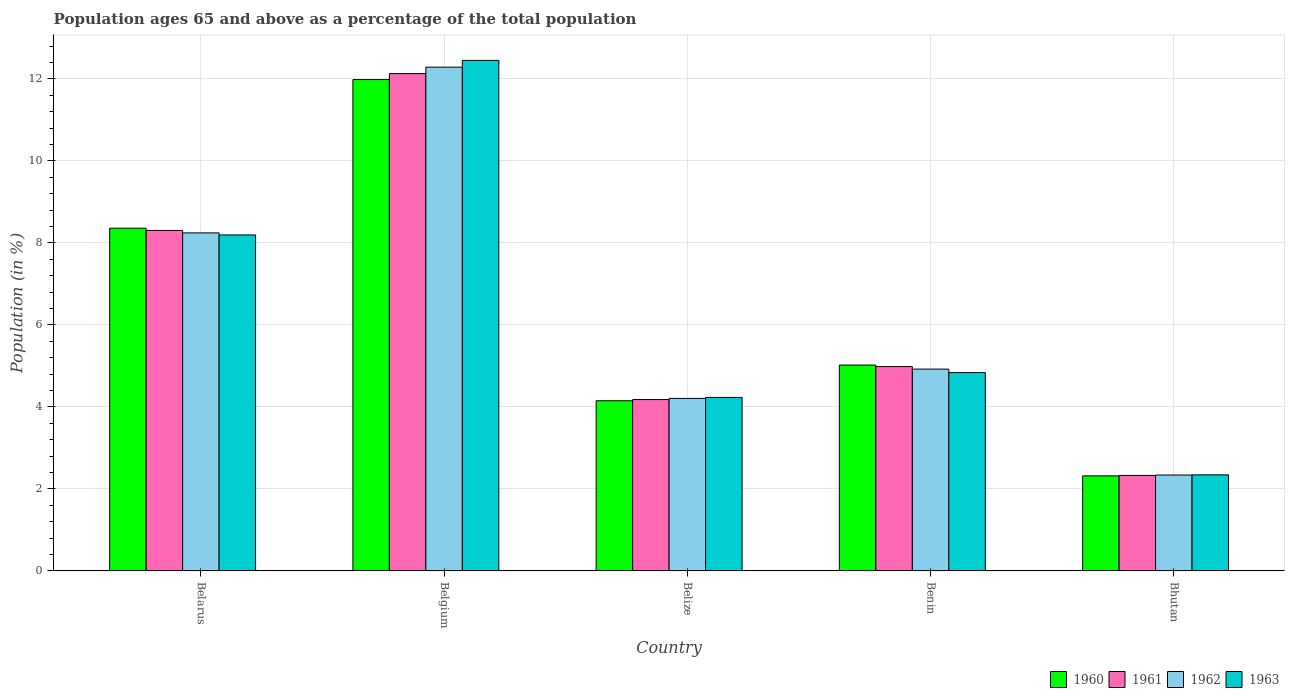Are the number of bars per tick equal to the number of legend labels?
Provide a succinct answer. Yes. How many bars are there on the 1st tick from the right?
Your answer should be compact. 4. What is the label of the 1st group of bars from the left?
Provide a short and direct response. Belarus. In how many cases, is the number of bars for a given country not equal to the number of legend labels?
Your response must be concise. 0. What is the percentage of the population ages 65 and above in 1963 in Bhutan?
Your response must be concise. 2.34. Across all countries, what is the maximum percentage of the population ages 65 and above in 1961?
Offer a terse response. 12.13. Across all countries, what is the minimum percentage of the population ages 65 and above in 1961?
Give a very brief answer. 2.33. In which country was the percentage of the population ages 65 and above in 1962 maximum?
Ensure brevity in your answer.  Belgium. In which country was the percentage of the population ages 65 and above in 1963 minimum?
Make the answer very short. Bhutan. What is the total percentage of the population ages 65 and above in 1961 in the graph?
Provide a short and direct response. 31.93. What is the difference between the percentage of the population ages 65 and above in 1960 in Belarus and that in Belgium?
Your answer should be very brief. -3.63. What is the difference between the percentage of the population ages 65 and above in 1960 in Benin and the percentage of the population ages 65 and above in 1963 in Belize?
Provide a short and direct response. 0.79. What is the average percentage of the population ages 65 and above in 1962 per country?
Your answer should be very brief. 6.4. What is the difference between the percentage of the population ages 65 and above of/in 1960 and percentage of the population ages 65 and above of/in 1963 in Bhutan?
Give a very brief answer. -0.03. In how many countries, is the percentage of the population ages 65 and above in 1961 greater than 12?
Ensure brevity in your answer.  1. What is the ratio of the percentage of the population ages 65 and above in 1961 in Belarus to that in Bhutan?
Offer a terse response. 3.57. What is the difference between the highest and the second highest percentage of the population ages 65 and above in 1961?
Offer a terse response. -3.83. What is the difference between the highest and the lowest percentage of the population ages 65 and above in 1963?
Offer a very short reply. 10.11. In how many countries, is the percentage of the population ages 65 and above in 1962 greater than the average percentage of the population ages 65 and above in 1962 taken over all countries?
Offer a very short reply. 2. Is it the case that in every country, the sum of the percentage of the population ages 65 and above in 1960 and percentage of the population ages 65 and above in 1961 is greater than the sum of percentage of the population ages 65 and above in 1963 and percentage of the population ages 65 and above in 1962?
Provide a succinct answer. No. What does the 2nd bar from the left in Belize represents?
Keep it short and to the point. 1961. Is it the case that in every country, the sum of the percentage of the population ages 65 and above in 1962 and percentage of the population ages 65 and above in 1960 is greater than the percentage of the population ages 65 and above in 1963?
Give a very brief answer. Yes. Are the values on the major ticks of Y-axis written in scientific E-notation?
Make the answer very short. No. Does the graph contain any zero values?
Keep it short and to the point. No. Where does the legend appear in the graph?
Keep it short and to the point. Bottom right. How many legend labels are there?
Keep it short and to the point. 4. What is the title of the graph?
Your response must be concise. Population ages 65 and above as a percentage of the total population. What is the label or title of the X-axis?
Your answer should be very brief. Country. What is the label or title of the Y-axis?
Give a very brief answer. Population (in %). What is the Population (in %) in 1960 in Belarus?
Make the answer very short. 8.36. What is the Population (in %) in 1961 in Belarus?
Your answer should be compact. 8.3. What is the Population (in %) of 1962 in Belarus?
Provide a succinct answer. 8.25. What is the Population (in %) in 1963 in Belarus?
Offer a terse response. 8.2. What is the Population (in %) in 1960 in Belgium?
Provide a short and direct response. 11.99. What is the Population (in %) of 1961 in Belgium?
Offer a terse response. 12.13. What is the Population (in %) in 1962 in Belgium?
Your answer should be compact. 12.29. What is the Population (in %) in 1963 in Belgium?
Keep it short and to the point. 12.45. What is the Population (in %) of 1960 in Belize?
Make the answer very short. 4.15. What is the Population (in %) in 1961 in Belize?
Make the answer very short. 4.18. What is the Population (in %) in 1962 in Belize?
Your response must be concise. 4.21. What is the Population (in %) of 1963 in Belize?
Give a very brief answer. 4.23. What is the Population (in %) in 1960 in Benin?
Your answer should be very brief. 5.02. What is the Population (in %) in 1961 in Benin?
Make the answer very short. 4.98. What is the Population (in %) in 1962 in Benin?
Your answer should be compact. 4.92. What is the Population (in %) in 1963 in Benin?
Your answer should be compact. 4.84. What is the Population (in %) of 1960 in Bhutan?
Offer a terse response. 2.32. What is the Population (in %) of 1961 in Bhutan?
Offer a very short reply. 2.33. What is the Population (in %) in 1962 in Bhutan?
Ensure brevity in your answer.  2.34. What is the Population (in %) in 1963 in Bhutan?
Your answer should be very brief. 2.34. Across all countries, what is the maximum Population (in %) of 1960?
Provide a short and direct response. 11.99. Across all countries, what is the maximum Population (in %) in 1961?
Ensure brevity in your answer.  12.13. Across all countries, what is the maximum Population (in %) in 1962?
Make the answer very short. 12.29. Across all countries, what is the maximum Population (in %) of 1963?
Provide a succinct answer. 12.45. Across all countries, what is the minimum Population (in %) in 1960?
Keep it short and to the point. 2.32. Across all countries, what is the minimum Population (in %) of 1961?
Offer a terse response. 2.33. Across all countries, what is the minimum Population (in %) in 1962?
Your response must be concise. 2.34. Across all countries, what is the minimum Population (in %) in 1963?
Give a very brief answer. 2.34. What is the total Population (in %) in 1960 in the graph?
Your response must be concise. 31.83. What is the total Population (in %) in 1961 in the graph?
Your response must be concise. 31.93. What is the total Population (in %) in 1962 in the graph?
Give a very brief answer. 32. What is the total Population (in %) of 1963 in the graph?
Offer a very short reply. 32.06. What is the difference between the Population (in %) of 1960 in Belarus and that in Belgium?
Make the answer very short. -3.63. What is the difference between the Population (in %) of 1961 in Belarus and that in Belgium?
Offer a terse response. -3.83. What is the difference between the Population (in %) in 1962 in Belarus and that in Belgium?
Your answer should be very brief. -4.04. What is the difference between the Population (in %) of 1963 in Belarus and that in Belgium?
Ensure brevity in your answer.  -4.26. What is the difference between the Population (in %) of 1960 in Belarus and that in Belize?
Ensure brevity in your answer.  4.21. What is the difference between the Population (in %) in 1961 in Belarus and that in Belize?
Make the answer very short. 4.13. What is the difference between the Population (in %) in 1962 in Belarus and that in Belize?
Offer a terse response. 4.04. What is the difference between the Population (in %) of 1963 in Belarus and that in Belize?
Provide a succinct answer. 3.96. What is the difference between the Population (in %) of 1960 in Belarus and that in Benin?
Provide a short and direct response. 3.34. What is the difference between the Population (in %) in 1961 in Belarus and that in Benin?
Your answer should be compact. 3.32. What is the difference between the Population (in %) in 1962 in Belarus and that in Benin?
Your answer should be very brief. 3.32. What is the difference between the Population (in %) of 1963 in Belarus and that in Benin?
Keep it short and to the point. 3.36. What is the difference between the Population (in %) in 1960 in Belarus and that in Bhutan?
Your answer should be very brief. 6.04. What is the difference between the Population (in %) of 1961 in Belarus and that in Bhutan?
Your answer should be very brief. 5.98. What is the difference between the Population (in %) of 1962 in Belarus and that in Bhutan?
Provide a succinct answer. 5.91. What is the difference between the Population (in %) in 1963 in Belarus and that in Bhutan?
Your response must be concise. 5.85. What is the difference between the Population (in %) of 1960 in Belgium and that in Belize?
Your response must be concise. 7.84. What is the difference between the Population (in %) of 1961 in Belgium and that in Belize?
Offer a terse response. 7.95. What is the difference between the Population (in %) in 1962 in Belgium and that in Belize?
Provide a short and direct response. 8.08. What is the difference between the Population (in %) in 1963 in Belgium and that in Belize?
Make the answer very short. 8.22. What is the difference between the Population (in %) of 1960 in Belgium and that in Benin?
Keep it short and to the point. 6.96. What is the difference between the Population (in %) in 1961 in Belgium and that in Benin?
Offer a terse response. 7.15. What is the difference between the Population (in %) of 1962 in Belgium and that in Benin?
Your answer should be very brief. 7.37. What is the difference between the Population (in %) in 1963 in Belgium and that in Benin?
Your answer should be very brief. 7.62. What is the difference between the Population (in %) of 1960 in Belgium and that in Bhutan?
Give a very brief answer. 9.67. What is the difference between the Population (in %) of 1961 in Belgium and that in Bhutan?
Provide a succinct answer. 9.8. What is the difference between the Population (in %) of 1962 in Belgium and that in Bhutan?
Offer a terse response. 9.95. What is the difference between the Population (in %) of 1963 in Belgium and that in Bhutan?
Give a very brief answer. 10.11. What is the difference between the Population (in %) of 1960 in Belize and that in Benin?
Your response must be concise. -0.87. What is the difference between the Population (in %) of 1961 in Belize and that in Benin?
Give a very brief answer. -0.8. What is the difference between the Population (in %) of 1962 in Belize and that in Benin?
Give a very brief answer. -0.71. What is the difference between the Population (in %) in 1963 in Belize and that in Benin?
Provide a short and direct response. -0.61. What is the difference between the Population (in %) in 1960 in Belize and that in Bhutan?
Your answer should be very brief. 1.83. What is the difference between the Population (in %) in 1961 in Belize and that in Bhutan?
Your answer should be very brief. 1.85. What is the difference between the Population (in %) in 1962 in Belize and that in Bhutan?
Your response must be concise. 1.87. What is the difference between the Population (in %) in 1963 in Belize and that in Bhutan?
Offer a very short reply. 1.89. What is the difference between the Population (in %) of 1960 in Benin and that in Bhutan?
Give a very brief answer. 2.7. What is the difference between the Population (in %) of 1961 in Benin and that in Bhutan?
Your answer should be very brief. 2.65. What is the difference between the Population (in %) of 1962 in Benin and that in Bhutan?
Make the answer very short. 2.58. What is the difference between the Population (in %) of 1963 in Benin and that in Bhutan?
Offer a terse response. 2.49. What is the difference between the Population (in %) of 1960 in Belarus and the Population (in %) of 1961 in Belgium?
Keep it short and to the point. -3.77. What is the difference between the Population (in %) of 1960 in Belarus and the Population (in %) of 1962 in Belgium?
Offer a terse response. -3.93. What is the difference between the Population (in %) of 1960 in Belarus and the Population (in %) of 1963 in Belgium?
Your answer should be very brief. -4.09. What is the difference between the Population (in %) in 1961 in Belarus and the Population (in %) in 1962 in Belgium?
Provide a succinct answer. -3.98. What is the difference between the Population (in %) in 1961 in Belarus and the Population (in %) in 1963 in Belgium?
Keep it short and to the point. -4.15. What is the difference between the Population (in %) of 1962 in Belarus and the Population (in %) of 1963 in Belgium?
Keep it short and to the point. -4.21. What is the difference between the Population (in %) in 1960 in Belarus and the Population (in %) in 1961 in Belize?
Your response must be concise. 4.18. What is the difference between the Population (in %) of 1960 in Belarus and the Population (in %) of 1962 in Belize?
Provide a succinct answer. 4.15. What is the difference between the Population (in %) in 1960 in Belarus and the Population (in %) in 1963 in Belize?
Your response must be concise. 4.13. What is the difference between the Population (in %) of 1961 in Belarus and the Population (in %) of 1962 in Belize?
Your answer should be compact. 4.1. What is the difference between the Population (in %) of 1961 in Belarus and the Population (in %) of 1963 in Belize?
Offer a very short reply. 4.07. What is the difference between the Population (in %) of 1962 in Belarus and the Population (in %) of 1963 in Belize?
Your answer should be very brief. 4.01. What is the difference between the Population (in %) in 1960 in Belarus and the Population (in %) in 1961 in Benin?
Make the answer very short. 3.38. What is the difference between the Population (in %) of 1960 in Belarus and the Population (in %) of 1962 in Benin?
Offer a very short reply. 3.44. What is the difference between the Population (in %) of 1960 in Belarus and the Population (in %) of 1963 in Benin?
Provide a short and direct response. 3.52. What is the difference between the Population (in %) of 1961 in Belarus and the Population (in %) of 1962 in Benin?
Provide a short and direct response. 3.38. What is the difference between the Population (in %) of 1961 in Belarus and the Population (in %) of 1963 in Benin?
Provide a succinct answer. 3.47. What is the difference between the Population (in %) of 1962 in Belarus and the Population (in %) of 1963 in Benin?
Offer a very short reply. 3.41. What is the difference between the Population (in %) of 1960 in Belarus and the Population (in %) of 1961 in Bhutan?
Offer a terse response. 6.03. What is the difference between the Population (in %) of 1960 in Belarus and the Population (in %) of 1962 in Bhutan?
Give a very brief answer. 6.02. What is the difference between the Population (in %) of 1960 in Belarus and the Population (in %) of 1963 in Bhutan?
Make the answer very short. 6.02. What is the difference between the Population (in %) of 1961 in Belarus and the Population (in %) of 1962 in Bhutan?
Provide a short and direct response. 5.97. What is the difference between the Population (in %) of 1961 in Belarus and the Population (in %) of 1963 in Bhutan?
Ensure brevity in your answer.  5.96. What is the difference between the Population (in %) in 1962 in Belarus and the Population (in %) in 1963 in Bhutan?
Give a very brief answer. 5.9. What is the difference between the Population (in %) of 1960 in Belgium and the Population (in %) of 1961 in Belize?
Give a very brief answer. 7.81. What is the difference between the Population (in %) of 1960 in Belgium and the Population (in %) of 1962 in Belize?
Keep it short and to the point. 7.78. What is the difference between the Population (in %) in 1960 in Belgium and the Population (in %) in 1963 in Belize?
Offer a very short reply. 7.75. What is the difference between the Population (in %) in 1961 in Belgium and the Population (in %) in 1962 in Belize?
Provide a succinct answer. 7.92. What is the difference between the Population (in %) of 1961 in Belgium and the Population (in %) of 1963 in Belize?
Give a very brief answer. 7.9. What is the difference between the Population (in %) in 1962 in Belgium and the Population (in %) in 1963 in Belize?
Ensure brevity in your answer.  8.06. What is the difference between the Population (in %) in 1960 in Belgium and the Population (in %) in 1961 in Benin?
Your answer should be compact. 7. What is the difference between the Population (in %) of 1960 in Belgium and the Population (in %) of 1962 in Benin?
Provide a succinct answer. 7.06. What is the difference between the Population (in %) of 1960 in Belgium and the Population (in %) of 1963 in Benin?
Your response must be concise. 7.15. What is the difference between the Population (in %) in 1961 in Belgium and the Population (in %) in 1962 in Benin?
Keep it short and to the point. 7.21. What is the difference between the Population (in %) of 1961 in Belgium and the Population (in %) of 1963 in Benin?
Your answer should be very brief. 7.29. What is the difference between the Population (in %) of 1962 in Belgium and the Population (in %) of 1963 in Benin?
Offer a terse response. 7.45. What is the difference between the Population (in %) in 1960 in Belgium and the Population (in %) in 1961 in Bhutan?
Provide a succinct answer. 9.66. What is the difference between the Population (in %) of 1960 in Belgium and the Population (in %) of 1962 in Bhutan?
Your answer should be very brief. 9.65. What is the difference between the Population (in %) in 1960 in Belgium and the Population (in %) in 1963 in Bhutan?
Offer a terse response. 9.64. What is the difference between the Population (in %) of 1961 in Belgium and the Population (in %) of 1962 in Bhutan?
Your response must be concise. 9.79. What is the difference between the Population (in %) of 1961 in Belgium and the Population (in %) of 1963 in Bhutan?
Your answer should be compact. 9.79. What is the difference between the Population (in %) in 1962 in Belgium and the Population (in %) in 1963 in Bhutan?
Your response must be concise. 9.95. What is the difference between the Population (in %) of 1960 in Belize and the Population (in %) of 1961 in Benin?
Give a very brief answer. -0.83. What is the difference between the Population (in %) in 1960 in Belize and the Population (in %) in 1962 in Benin?
Your response must be concise. -0.77. What is the difference between the Population (in %) of 1960 in Belize and the Population (in %) of 1963 in Benin?
Provide a short and direct response. -0.69. What is the difference between the Population (in %) of 1961 in Belize and the Population (in %) of 1962 in Benin?
Offer a terse response. -0.74. What is the difference between the Population (in %) in 1961 in Belize and the Population (in %) in 1963 in Benin?
Make the answer very short. -0.66. What is the difference between the Population (in %) of 1962 in Belize and the Population (in %) of 1963 in Benin?
Make the answer very short. -0.63. What is the difference between the Population (in %) in 1960 in Belize and the Population (in %) in 1961 in Bhutan?
Offer a terse response. 1.82. What is the difference between the Population (in %) in 1960 in Belize and the Population (in %) in 1962 in Bhutan?
Your answer should be compact. 1.81. What is the difference between the Population (in %) of 1960 in Belize and the Population (in %) of 1963 in Bhutan?
Keep it short and to the point. 1.81. What is the difference between the Population (in %) in 1961 in Belize and the Population (in %) in 1962 in Bhutan?
Ensure brevity in your answer.  1.84. What is the difference between the Population (in %) in 1961 in Belize and the Population (in %) in 1963 in Bhutan?
Ensure brevity in your answer.  1.84. What is the difference between the Population (in %) in 1962 in Belize and the Population (in %) in 1963 in Bhutan?
Offer a terse response. 1.87. What is the difference between the Population (in %) of 1960 in Benin and the Population (in %) of 1961 in Bhutan?
Provide a short and direct response. 2.69. What is the difference between the Population (in %) of 1960 in Benin and the Population (in %) of 1962 in Bhutan?
Provide a succinct answer. 2.68. What is the difference between the Population (in %) in 1960 in Benin and the Population (in %) in 1963 in Bhutan?
Make the answer very short. 2.68. What is the difference between the Population (in %) of 1961 in Benin and the Population (in %) of 1962 in Bhutan?
Your response must be concise. 2.65. What is the difference between the Population (in %) of 1961 in Benin and the Population (in %) of 1963 in Bhutan?
Your answer should be compact. 2.64. What is the difference between the Population (in %) in 1962 in Benin and the Population (in %) in 1963 in Bhutan?
Your answer should be compact. 2.58. What is the average Population (in %) in 1960 per country?
Your answer should be compact. 6.37. What is the average Population (in %) in 1961 per country?
Your response must be concise. 6.39. What is the average Population (in %) of 1962 per country?
Make the answer very short. 6.4. What is the average Population (in %) in 1963 per country?
Offer a terse response. 6.41. What is the difference between the Population (in %) in 1960 and Population (in %) in 1961 in Belarus?
Offer a terse response. 0.05. What is the difference between the Population (in %) in 1960 and Population (in %) in 1962 in Belarus?
Provide a succinct answer. 0.11. What is the difference between the Population (in %) of 1960 and Population (in %) of 1963 in Belarus?
Offer a terse response. 0.16. What is the difference between the Population (in %) in 1961 and Population (in %) in 1962 in Belarus?
Offer a very short reply. 0.06. What is the difference between the Population (in %) in 1961 and Population (in %) in 1963 in Belarus?
Your answer should be very brief. 0.11. What is the difference between the Population (in %) in 1962 and Population (in %) in 1963 in Belarus?
Make the answer very short. 0.05. What is the difference between the Population (in %) of 1960 and Population (in %) of 1961 in Belgium?
Provide a short and direct response. -0.15. What is the difference between the Population (in %) of 1960 and Population (in %) of 1962 in Belgium?
Your response must be concise. -0.3. What is the difference between the Population (in %) in 1960 and Population (in %) in 1963 in Belgium?
Provide a succinct answer. -0.47. What is the difference between the Population (in %) in 1961 and Population (in %) in 1962 in Belgium?
Provide a short and direct response. -0.16. What is the difference between the Population (in %) in 1961 and Population (in %) in 1963 in Belgium?
Your answer should be very brief. -0.32. What is the difference between the Population (in %) in 1962 and Population (in %) in 1963 in Belgium?
Provide a short and direct response. -0.16. What is the difference between the Population (in %) of 1960 and Population (in %) of 1961 in Belize?
Provide a succinct answer. -0.03. What is the difference between the Population (in %) in 1960 and Population (in %) in 1962 in Belize?
Keep it short and to the point. -0.06. What is the difference between the Population (in %) of 1960 and Population (in %) of 1963 in Belize?
Your answer should be very brief. -0.08. What is the difference between the Population (in %) of 1961 and Population (in %) of 1962 in Belize?
Offer a terse response. -0.03. What is the difference between the Population (in %) in 1961 and Population (in %) in 1963 in Belize?
Make the answer very short. -0.05. What is the difference between the Population (in %) of 1962 and Population (in %) of 1963 in Belize?
Offer a very short reply. -0.02. What is the difference between the Population (in %) of 1960 and Population (in %) of 1961 in Benin?
Your answer should be very brief. 0.04. What is the difference between the Population (in %) of 1960 and Population (in %) of 1962 in Benin?
Keep it short and to the point. 0.1. What is the difference between the Population (in %) in 1960 and Population (in %) in 1963 in Benin?
Offer a very short reply. 0.18. What is the difference between the Population (in %) in 1961 and Population (in %) in 1962 in Benin?
Ensure brevity in your answer.  0.06. What is the difference between the Population (in %) of 1961 and Population (in %) of 1963 in Benin?
Your answer should be very brief. 0.15. What is the difference between the Population (in %) of 1962 and Population (in %) of 1963 in Benin?
Your answer should be compact. 0.09. What is the difference between the Population (in %) of 1960 and Population (in %) of 1961 in Bhutan?
Provide a succinct answer. -0.01. What is the difference between the Population (in %) in 1960 and Population (in %) in 1962 in Bhutan?
Your answer should be compact. -0.02. What is the difference between the Population (in %) of 1960 and Population (in %) of 1963 in Bhutan?
Your answer should be compact. -0.03. What is the difference between the Population (in %) of 1961 and Population (in %) of 1962 in Bhutan?
Offer a terse response. -0.01. What is the difference between the Population (in %) of 1961 and Population (in %) of 1963 in Bhutan?
Give a very brief answer. -0.01. What is the difference between the Population (in %) in 1962 and Population (in %) in 1963 in Bhutan?
Offer a terse response. -0. What is the ratio of the Population (in %) of 1960 in Belarus to that in Belgium?
Your answer should be compact. 0.7. What is the ratio of the Population (in %) of 1961 in Belarus to that in Belgium?
Provide a short and direct response. 0.68. What is the ratio of the Population (in %) of 1962 in Belarus to that in Belgium?
Keep it short and to the point. 0.67. What is the ratio of the Population (in %) in 1963 in Belarus to that in Belgium?
Your response must be concise. 0.66. What is the ratio of the Population (in %) in 1960 in Belarus to that in Belize?
Offer a terse response. 2.01. What is the ratio of the Population (in %) of 1961 in Belarus to that in Belize?
Give a very brief answer. 1.99. What is the ratio of the Population (in %) in 1962 in Belarus to that in Belize?
Make the answer very short. 1.96. What is the ratio of the Population (in %) in 1963 in Belarus to that in Belize?
Offer a terse response. 1.94. What is the ratio of the Population (in %) of 1960 in Belarus to that in Benin?
Your response must be concise. 1.66. What is the ratio of the Population (in %) of 1961 in Belarus to that in Benin?
Your answer should be very brief. 1.67. What is the ratio of the Population (in %) of 1962 in Belarus to that in Benin?
Provide a short and direct response. 1.67. What is the ratio of the Population (in %) of 1963 in Belarus to that in Benin?
Make the answer very short. 1.69. What is the ratio of the Population (in %) of 1960 in Belarus to that in Bhutan?
Your answer should be compact. 3.61. What is the ratio of the Population (in %) of 1961 in Belarus to that in Bhutan?
Provide a succinct answer. 3.57. What is the ratio of the Population (in %) of 1962 in Belarus to that in Bhutan?
Make the answer very short. 3.53. What is the ratio of the Population (in %) in 1963 in Belarus to that in Bhutan?
Provide a short and direct response. 3.5. What is the ratio of the Population (in %) of 1960 in Belgium to that in Belize?
Make the answer very short. 2.89. What is the ratio of the Population (in %) of 1961 in Belgium to that in Belize?
Provide a short and direct response. 2.9. What is the ratio of the Population (in %) of 1962 in Belgium to that in Belize?
Offer a terse response. 2.92. What is the ratio of the Population (in %) of 1963 in Belgium to that in Belize?
Your answer should be compact. 2.94. What is the ratio of the Population (in %) in 1960 in Belgium to that in Benin?
Ensure brevity in your answer.  2.39. What is the ratio of the Population (in %) of 1961 in Belgium to that in Benin?
Make the answer very short. 2.43. What is the ratio of the Population (in %) of 1962 in Belgium to that in Benin?
Your answer should be compact. 2.5. What is the ratio of the Population (in %) of 1963 in Belgium to that in Benin?
Your answer should be very brief. 2.57. What is the ratio of the Population (in %) in 1960 in Belgium to that in Bhutan?
Provide a succinct answer. 5.17. What is the ratio of the Population (in %) of 1961 in Belgium to that in Bhutan?
Your answer should be very brief. 5.21. What is the ratio of the Population (in %) in 1962 in Belgium to that in Bhutan?
Provide a short and direct response. 5.25. What is the ratio of the Population (in %) in 1963 in Belgium to that in Bhutan?
Your answer should be compact. 5.32. What is the ratio of the Population (in %) in 1960 in Belize to that in Benin?
Keep it short and to the point. 0.83. What is the ratio of the Population (in %) of 1961 in Belize to that in Benin?
Your response must be concise. 0.84. What is the ratio of the Population (in %) in 1962 in Belize to that in Benin?
Provide a succinct answer. 0.85. What is the ratio of the Population (in %) in 1963 in Belize to that in Benin?
Provide a short and direct response. 0.87. What is the ratio of the Population (in %) in 1960 in Belize to that in Bhutan?
Your answer should be very brief. 1.79. What is the ratio of the Population (in %) in 1961 in Belize to that in Bhutan?
Give a very brief answer. 1.79. What is the ratio of the Population (in %) of 1962 in Belize to that in Bhutan?
Keep it short and to the point. 1.8. What is the ratio of the Population (in %) in 1963 in Belize to that in Bhutan?
Give a very brief answer. 1.81. What is the ratio of the Population (in %) in 1960 in Benin to that in Bhutan?
Provide a succinct answer. 2.17. What is the ratio of the Population (in %) of 1961 in Benin to that in Bhutan?
Offer a very short reply. 2.14. What is the ratio of the Population (in %) of 1962 in Benin to that in Bhutan?
Make the answer very short. 2.1. What is the ratio of the Population (in %) of 1963 in Benin to that in Bhutan?
Your answer should be very brief. 2.06. What is the difference between the highest and the second highest Population (in %) in 1960?
Offer a terse response. 3.63. What is the difference between the highest and the second highest Population (in %) of 1961?
Provide a succinct answer. 3.83. What is the difference between the highest and the second highest Population (in %) in 1962?
Keep it short and to the point. 4.04. What is the difference between the highest and the second highest Population (in %) of 1963?
Provide a succinct answer. 4.26. What is the difference between the highest and the lowest Population (in %) of 1960?
Offer a terse response. 9.67. What is the difference between the highest and the lowest Population (in %) in 1961?
Make the answer very short. 9.8. What is the difference between the highest and the lowest Population (in %) of 1962?
Offer a terse response. 9.95. What is the difference between the highest and the lowest Population (in %) of 1963?
Make the answer very short. 10.11. 